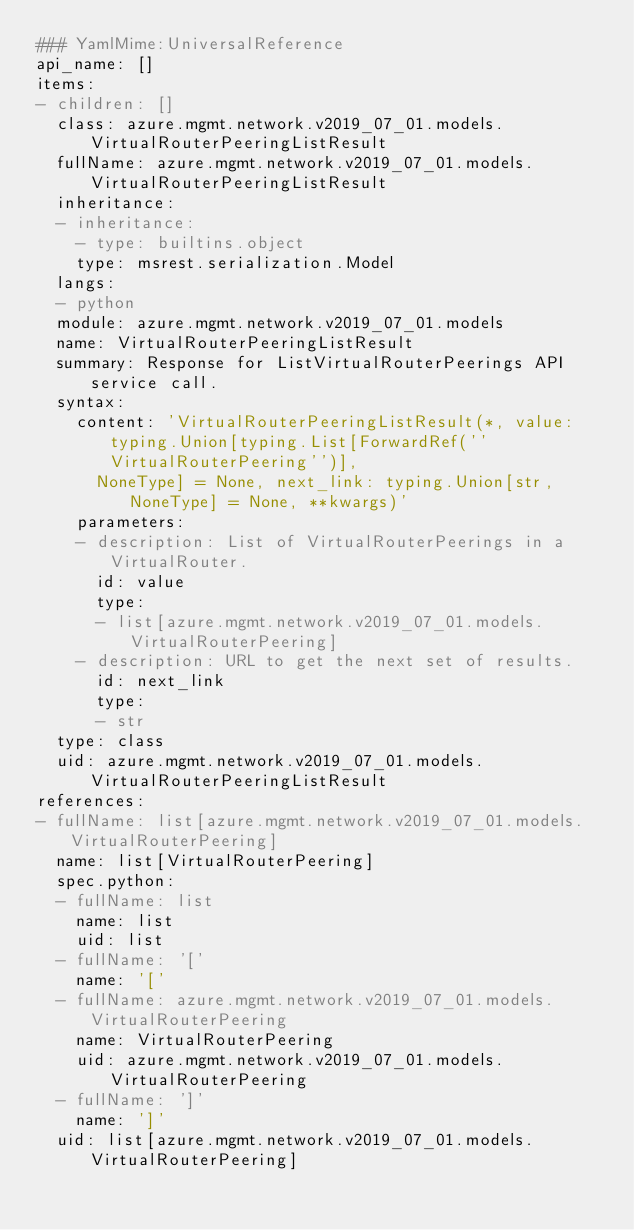Convert code to text. <code><loc_0><loc_0><loc_500><loc_500><_YAML_>### YamlMime:UniversalReference
api_name: []
items:
- children: []
  class: azure.mgmt.network.v2019_07_01.models.VirtualRouterPeeringListResult
  fullName: azure.mgmt.network.v2019_07_01.models.VirtualRouterPeeringListResult
  inheritance:
  - inheritance:
    - type: builtins.object
    type: msrest.serialization.Model
  langs:
  - python
  module: azure.mgmt.network.v2019_07_01.models
  name: VirtualRouterPeeringListResult
  summary: Response for ListVirtualRouterPeerings API service call.
  syntax:
    content: 'VirtualRouterPeeringListResult(*, value: typing.Union[typing.List[ForwardRef(''VirtualRouterPeering'')],
      NoneType] = None, next_link: typing.Union[str, NoneType] = None, **kwargs)'
    parameters:
    - description: List of VirtualRouterPeerings in a VirtualRouter.
      id: value
      type:
      - list[azure.mgmt.network.v2019_07_01.models.VirtualRouterPeering]
    - description: URL to get the next set of results.
      id: next_link
      type:
      - str
  type: class
  uid: azure.mgmt.network.v2019_07_01.models.VirtualRouterPeeringListResult
references:
- fullName: list[azure.mgmt.network.v2019_07_01.models.VirtualRouterPeering]
  name: list[VirtualRouterPeering]
  spec.python:
  - fullName: list
    name: list
    uid: list
  - fullName: '['
    name: '['
  - fullName: azure.mgmt.network.v2019_07_01.models.VirtualRouterPeering
    name: VirtualRouterPeering
    uid: azure.mgmt.network.v2019_07_01.models.VirtualRouterPeering
  - fullName: ']'
    name: ']'
  uid: list[azure.mgmt.network.v2019_07_01.models.VirtualRouterPeering]
</code> 